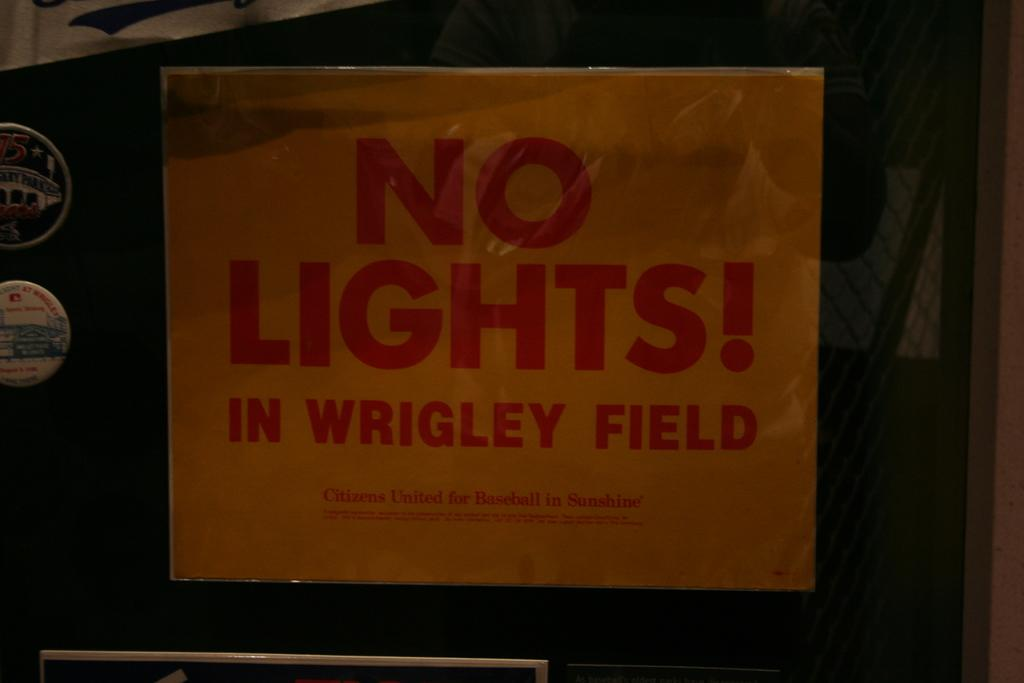Provide a one-sentence caption for the provided image. An old looking piece of paper that read No Light! In wrigley field. 